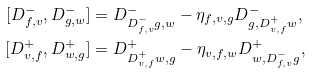<formula> <loc_0><loc_0><loc_500><loc_500>[ D ^ { - } _ { f , v } , D ^ { - } _ { g , w } ] & = D ^ { - } _ { D ^ { - } _ { f , v } g , w } - \eta _ { f , v , g } D ^ { - } _ { g , D ^ { + } _ { v , f } w } , \\ [ D ^ { + } _ { v , f } , D ^ { + } _ { w , g } ] & = D ^ { + } _ { D ^ { + } _ { v , f } w , g } - \eta _ { v , f , w } D ^ { + } _ { w , D ^ { - } _ { f , v } g } ,</formula> 